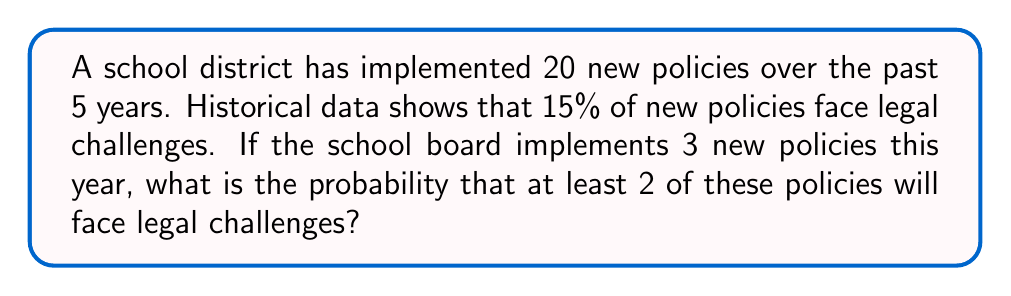Help me with this question. Let's approach this step-by-step using the binomial probability distribution:

1) First, we need to identify the parameters:
   - $n = 3$ (number of new policies)
   - $p = 0.15$ (probability of a legal challenge for each policy)
   - We want the probability of at least 2 policies facing challenges

2) The probability of at least 2 policies facing challenges is equal to:
   P(2 or 3 policies face challenges) = 1 - P(0 or 1 policy faces challenges)

3) We can calculate this using the binomial probability formula:
   $$P(X = k) = \binom{n}{k} p^k (1-p)^{n-k}$$

4) Let's calculate the probability of 0 challenges:
   $$P(X = 0) = \binom{3}{0} (0.15)^0 (0.85)^3 = 1 \cdot 1 \cdot 0.614125 = 0.614125$$

5) Now, let's calculate the probability of 1 challenge:
   $$P(X = 1) = \binom{3}{1} (0.15)^1 (0.85)^2 = 3 \cdot 0.15 \cdot 0.7225 = 0.325125$$

6) The probability of 0 or 1 challenge is:
   $$P(X \leq 1) = 0.614125 + 0.325125 = 0.93925$$

7) Therefore, the probability of at least 2 challenges is:
   $$P(X \geq 2) = 1 - P(X \leq 1) = 1 - 0.93925 = 0.06075$$

8) Converting to a percentage: 0.06075 * 100 = 6.075%
Answer: 6.075% 